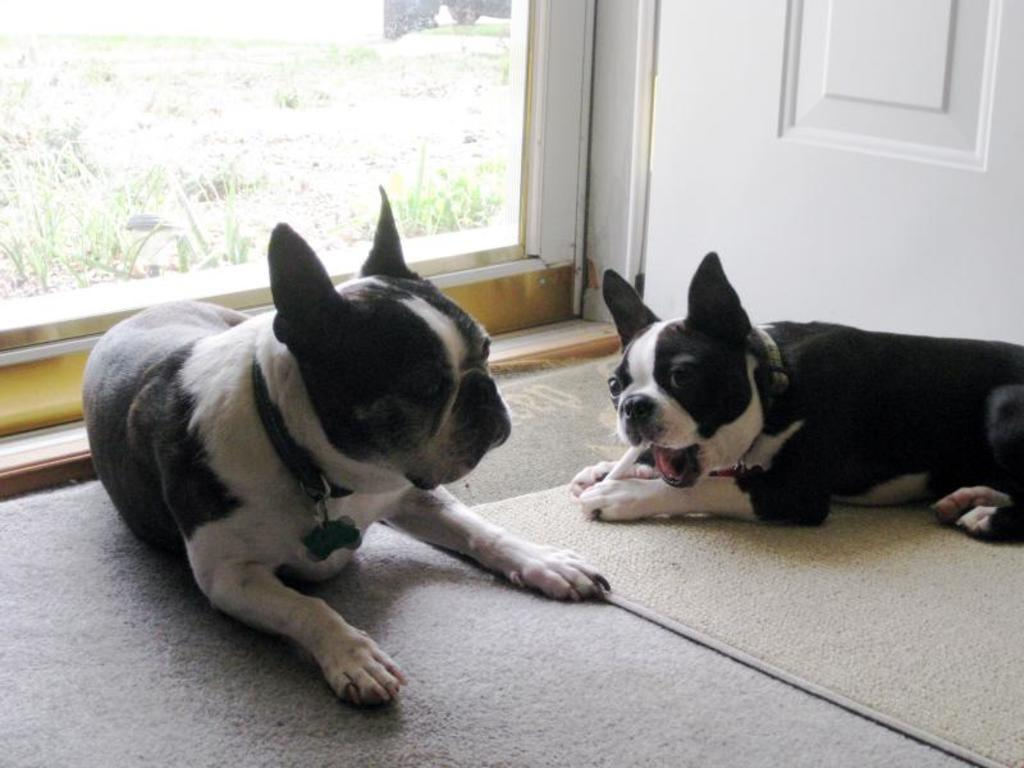How many dogs are present in the image? There are two dogs on the floor. Where is one of the dogs located? One dog is on a carpet. What can be seen in the background of the image? There is a wall and a glass window in the background. What type of authority does the dog on the carpet have in the image? There is no indication of any authority in the image, as it features two dogs on the floor and a background with a wall and a glass window. 